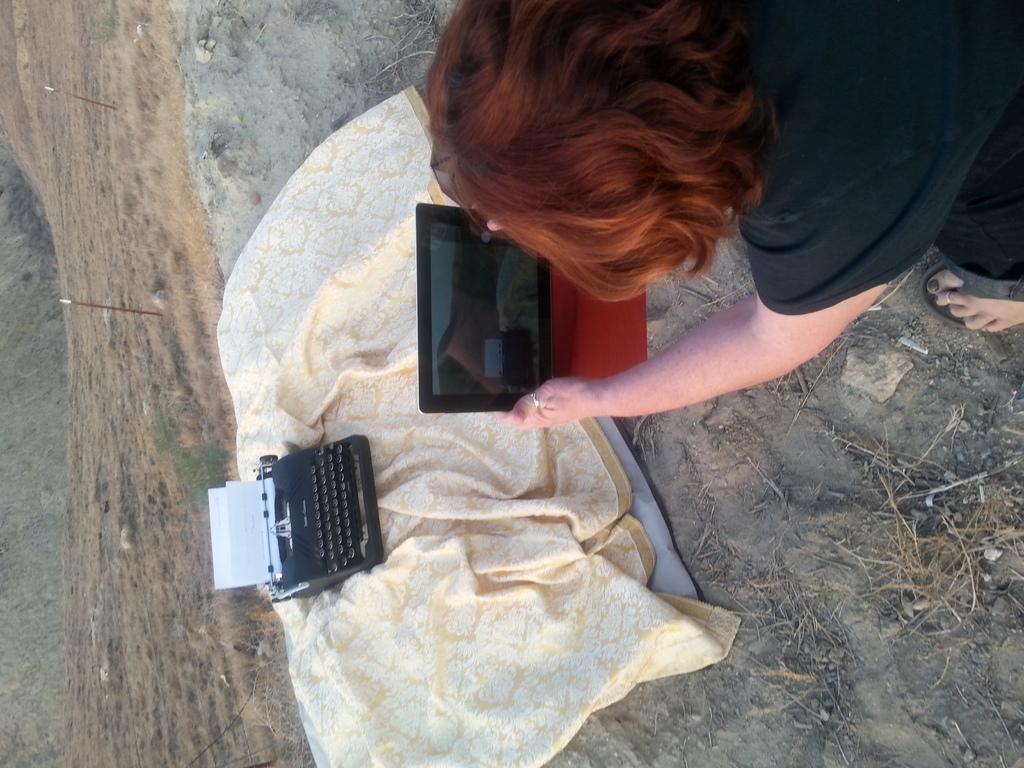What is the person in the image holding? The person is holding a tablet in the image. What is the person doing with the tablet? The person is capturing a picture with the tablet. What is the subject of the picture being captured? The subject of the picture is a typewriter. How is the typewriter positioned in the image? The typewriter is on a cloth. What can be seen in the background of the image? There is a muddy surface visible in the background of the image. How many masks are visible in the image? There are no masks visible in the image. What type of clocks can be seen in the picture being captured? There is no picture of clocks being captured in the image; the subject of the picture is a typewriter. 